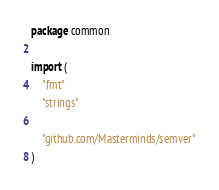<code> <loc_0><loc_0><loc_500><loc_500><_Go_>package common

import (
	"fmt"
	"strings"

	"github.com/Masterminds/semver"
)
</code> 